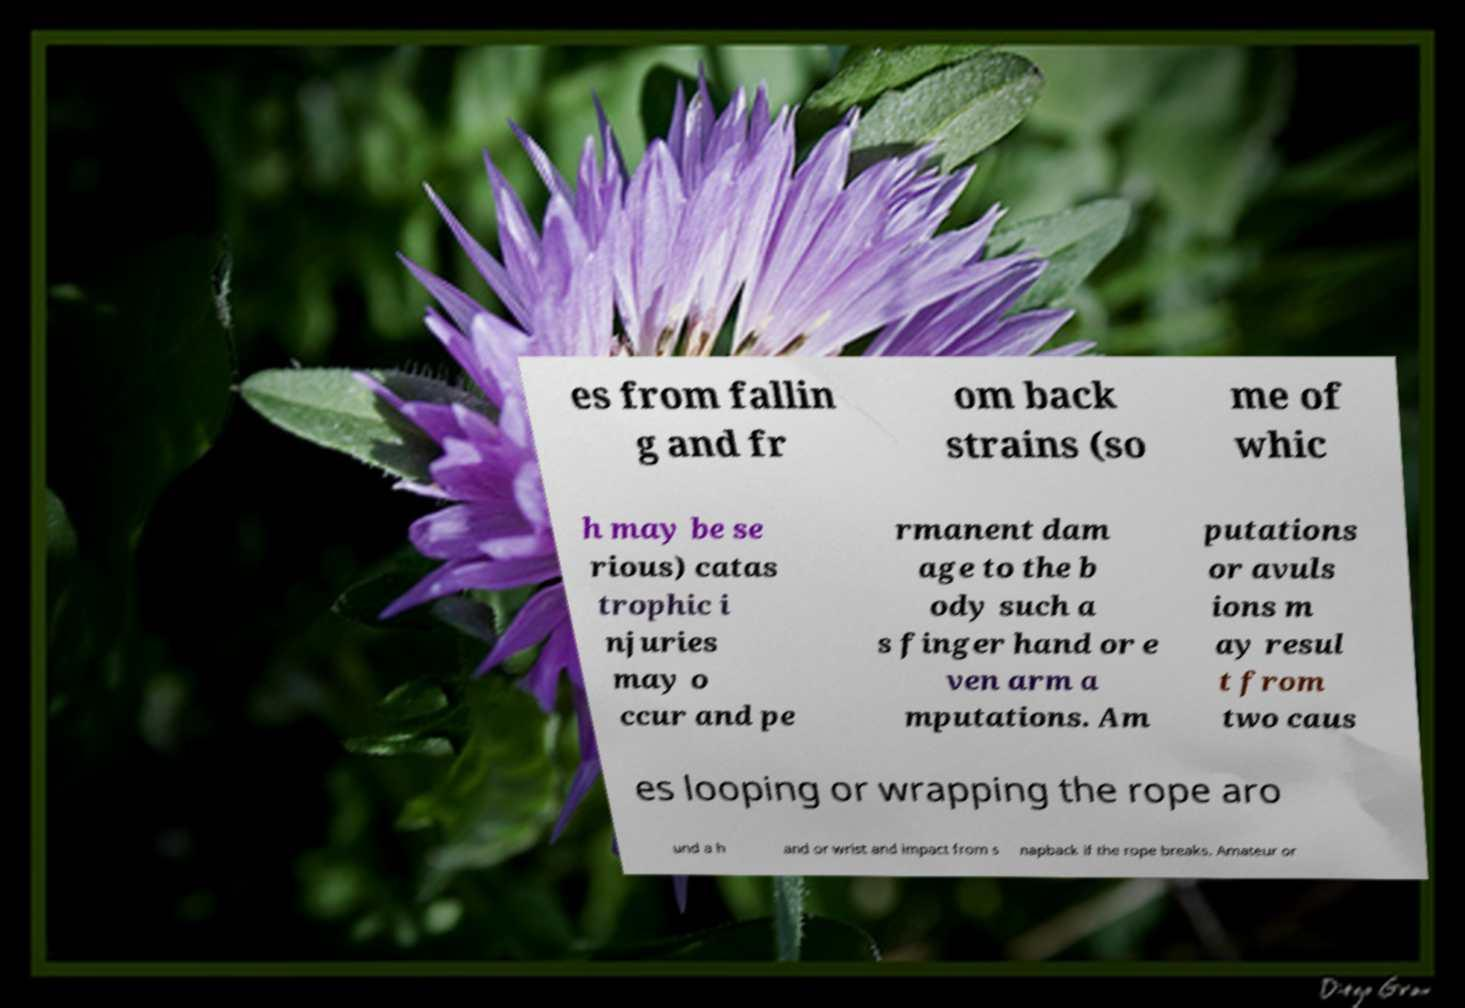What messages or text are displayed in this image? I need them in a readable, typed format. es from fallin g and fr om back strains (so me of whic h may be se rious) catas trophic i njuries may o ccur and pe rmanent dam age to the b ody such a s finger hand or e ven arm a mputations. Am putations or avuls ions m ay resul t from two caus es looping or wrapping the rope aro und a h and or wrist and impact from s napback if the rope breaks. Amateur or 